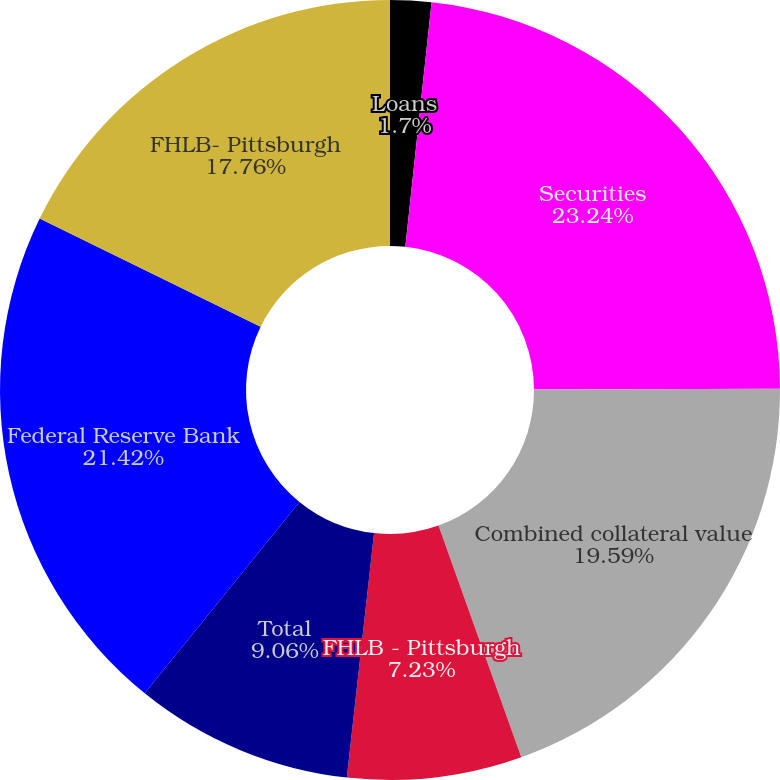Convert chart. <chart><loc_0><loc_0><loc_500><loc_500><pie_chart><fcel>Loans<fcel>Securities<fcel>Combined collateral value<fcel>FHLB - Pittsburgh<fcel>Total<fcel>Federal Reserve Bank<fcel>FHLB- Pittsburgh<nl><fcel>1.7%<fcel>23.25%<fcel>19.59%<fcel>7.23%<fcel>9.06%<fcel>21.42%<fcel>17.76%<nl></chart> 